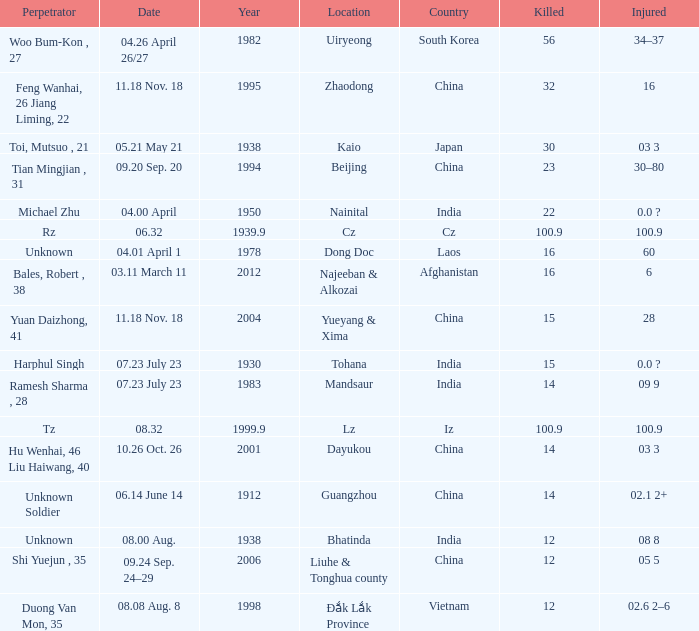What is the typical year when the date is "0 1978.0. 